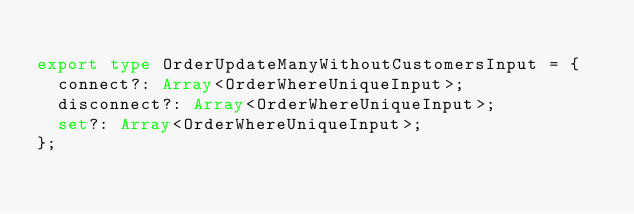<code> <loc_0><loc_0><loc_500><loc_500><_TypeScript_>
export type OrderUpdateManyWithoutCustomersInput = {
  connect?: Array<OrderWhereUniqueInput>;
  disconnect?: Array<OrderWhereUniqueInput>;
  set?: Array<OrderWhereUniqueInput>;
};
</code> 